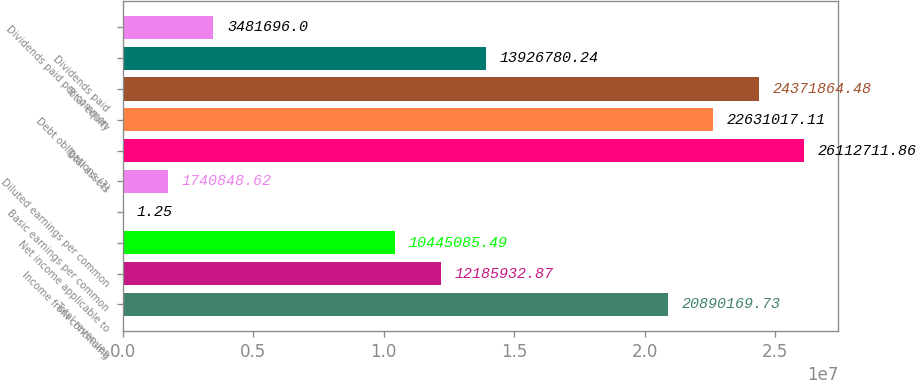Convert chart to OTSL. <chart><loc_0><loc_0><loc_500><loc_500><bar_chart><fcel>Total revenues<fcel>Income from continuing<fcel>Net income applicable to<fcel>Basic earnings per common<fcel>Diluted earnings per common<fcel>Total assets<fcel>Debt obligations (3)<fcel>Total equity<fcel>Dividends paid<fcel>Dividends paid per common<nl><fcel>2.08902e+07<fcel>1.21859e+07<fcel>1.04451e+07<fcel>1.25<fcel>1.74085e+06<fcel>2.61127e+07<fcel>2.2631e+07<fcel>2.43719e+07<fcel>1.39268e+07<fcel>3.4817e+06<nl></chart> 